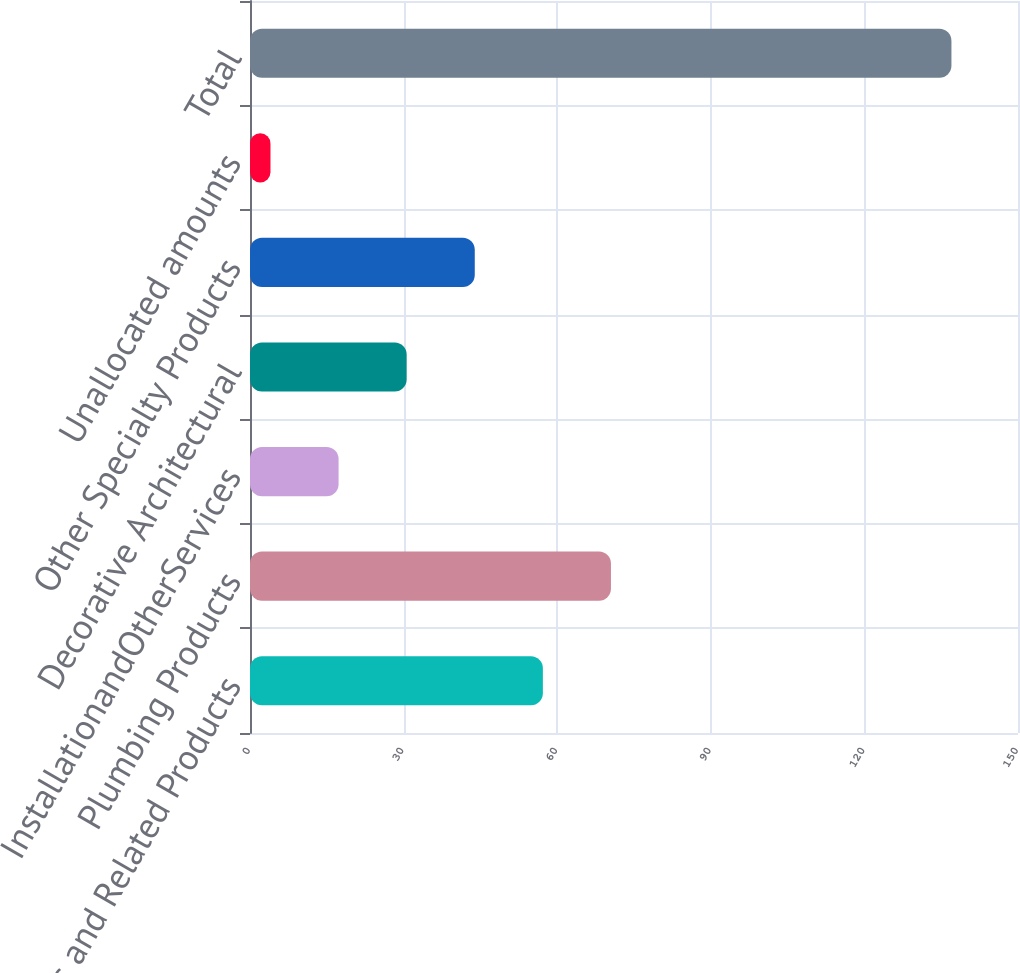Convert chart. <chart><loc_0><loc_0><loc_500><loc_500><bar_chart><fcel>Cabinets and Related Products<fcel>Plumbing Products<fcel>InstallationandOtherServices<fcel>Decorative Architectural<fcel>Other Specialty Products<fcel>Unallocated amounts<fcel>Total<nl><fcel>57.2<fcel>70.5<fcel>17.3<fcel>30.6<fcel>43.9<fcel>4<fcel>137<nl></chart> 